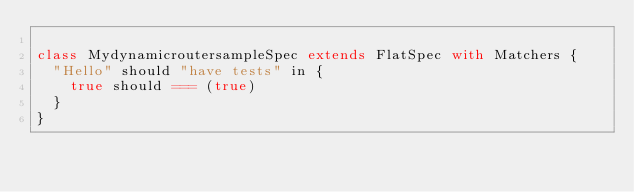<code> <loc_0><loc_0><loc_500><loc_500><_Scala_>
class MydynamicroutersampleSpec extends FlatSpec with Matchers {
  "Hello" should "have tests" in {
    true should === (true)
  }
}
</code> 